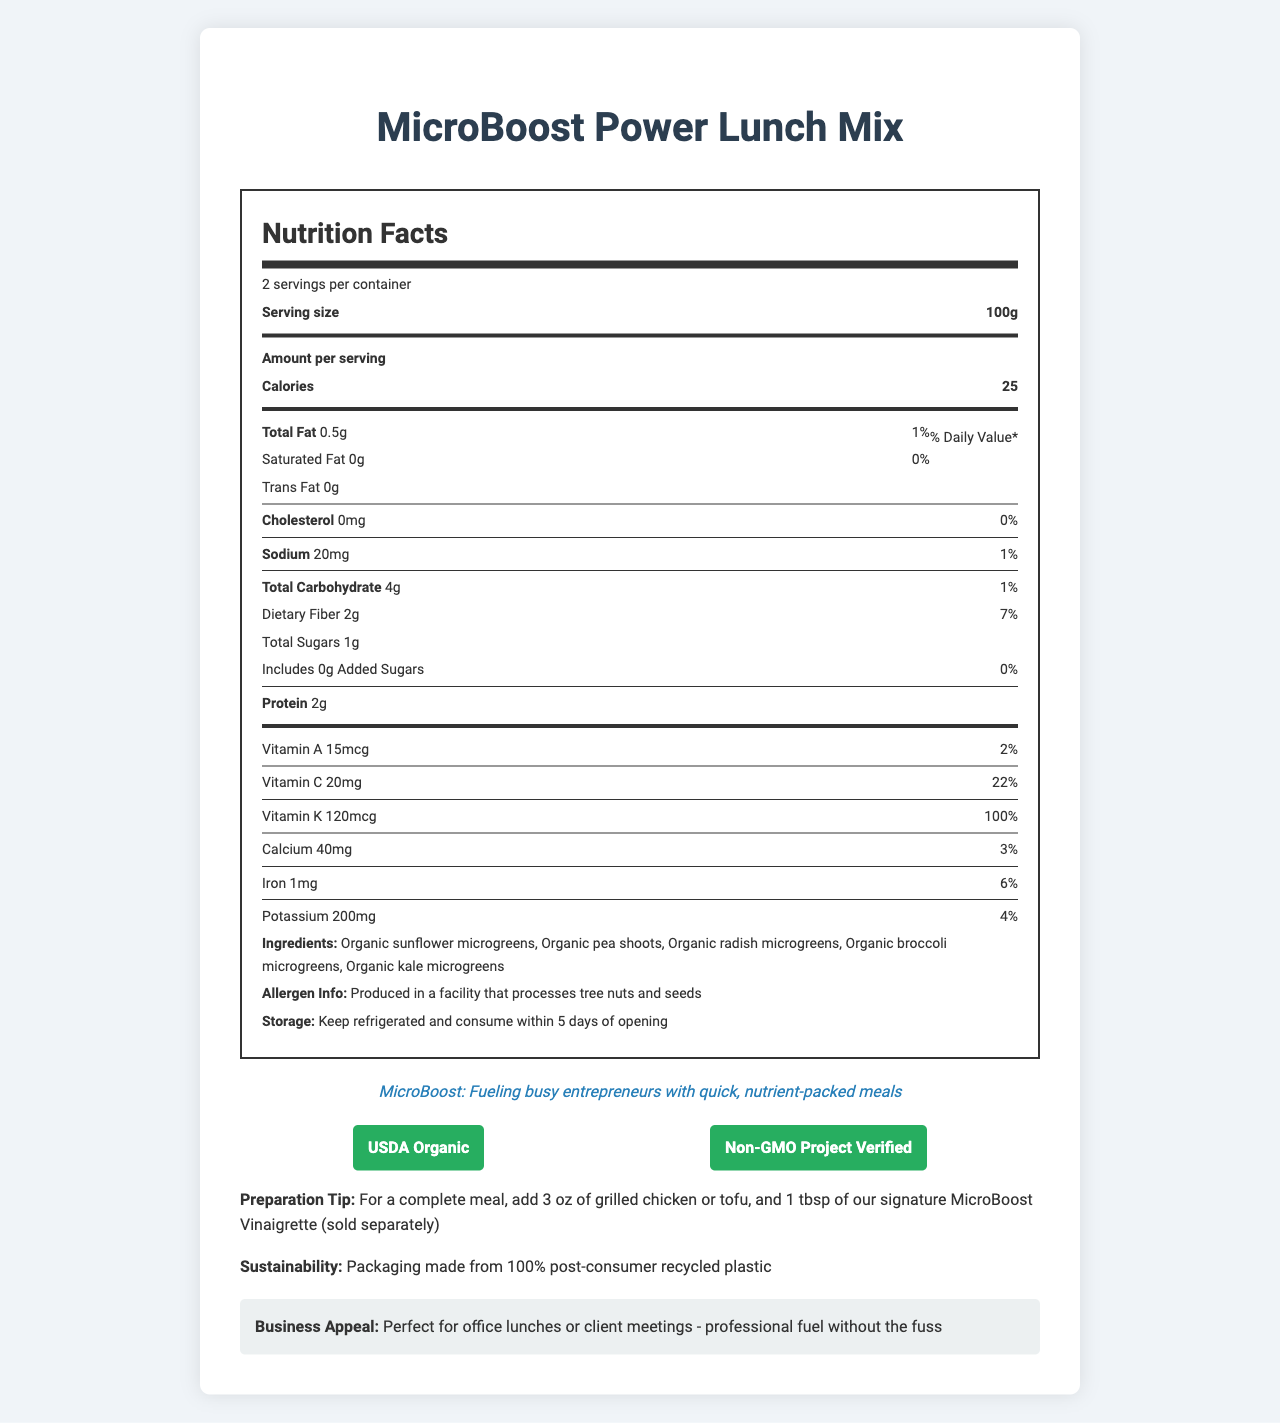what is the serving size? The serving size is clearly stated near the top of the Nutrition Facts section as 100g.
Answer: 100g how many servings are there per container? The document lists 2 servings per container at the beginning of the Nutrition Facts.
Answer: 2 what is the amount of dietary fiber per serving? Under the section listing nutrients, it shows dietary fiber as 2 grams per serving.
Answer: 2g how many calories are there per serving? The calories per serving are displayed prominently as 25 calories.
Answer: 25 which vitamins are present in the salad mix? The document lists Vitamin A, Vitamin C, and Vitamin K, along with their amounts and daily values.
Answer: Vitamin A, Vitamin C, Vitamin K is there any trans fat in the product? The document specifies there is 0g of Trans Fat.
Answer: No what is the brand's statement summarizing the purpose of the product? This brand statement is located towards the bottom of the document.
Answer: MicroBoost: Fueling busy entrepreneurs with quick, nutrient-packed meals what is the sodium content per serving? A. 10mg B. 20mg C. 5mg D. 50mg The sodium content per serving is listed as 20mg.
Answer: B. 20mg which certification(s) does the product have? I. USDA Organic II. Non-GMO Project Verified III. Fair Trade IV. Gluten-Free The product has both USDA Organic and Non-GMO Project Verified certifications.
Answer: I. USDA Organic, II. Non-GMO Project Verified are there any added sugars in the product? The document notes that there are 0 grams of added sugars.
Answer: No what is the primary ingredient in the MicroBoost Power Lunch Mix? The list of ingredients starts with Organic sunflower microgreens.
Answer: Organic sunflower microgreens describe the main idea of the document. The document covers a comprehensive overview of the product including its nutritional breakdown, storage and preparation tips, ingredient list, and the intended audience and use-case for the product.
Answer: The MicroBoost Power Lunch Mix is a nutrient-dense, microgreens-based salad designed for convenient and quick lunch options. It is low in calories, with detailed nutrition facts, allergen information, storage instructions, and multiple certifications, making it suitable for busy professionals who prioritize health and sustainability. can I consume the product if I am allergic to tree nuts? The document states that the product is produced in a facility that processes tree nuts and seeds, but doesn't specify if it contains tree nuts directly.
Answer: Cannot be determined 